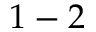Convert formula to latex. <formula><loc_0><loc_0><loc_500><loc_500>1 - 2</formula> 